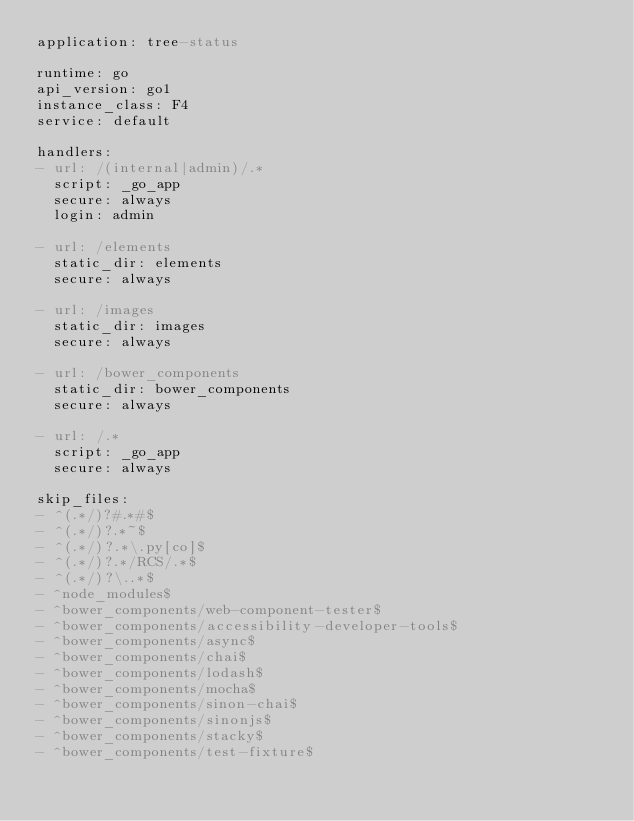<code> <loc_0><loc_0><loc_500><loc_500><_YAML_>application: tree-status

runtime: go
api_version: go1
instance_class: F4
service: default

handlers:
- url: /(internal|admin)/.*
  script: _go_app
  secure: always
  login: admin

- url: /elements
  static_dir: elements
  secure: always

- url: /images
  static_dir: images
  secure: always

- url: /bower_components
  static_dir: bower_components
  secure: always

- url: /.*
  script: _go_app
  secure: always

skip_files:
- ^(.*/)?#.*#$
- ^(.*/)?.*~$
- ^(.*/)?.*\.py[co]$
- ^(.*/)?.*/RCS/.*$
- ^(.*/)?\..*$
- ^node_modules$
- ^bower_components/web-component-tester$
- ^bower_components/accessibility-developer-tools$
- ^bower_components/async$
- ^bower_components/chai$
- ^bower_components/lodash$
- ^bower_components/mocha$
- ^bower_components/sinon-chai$
- ^bower_components/sinonjs$
- ^bower_components/stacky$
- ^bower_components/test-fixture$
</code> 